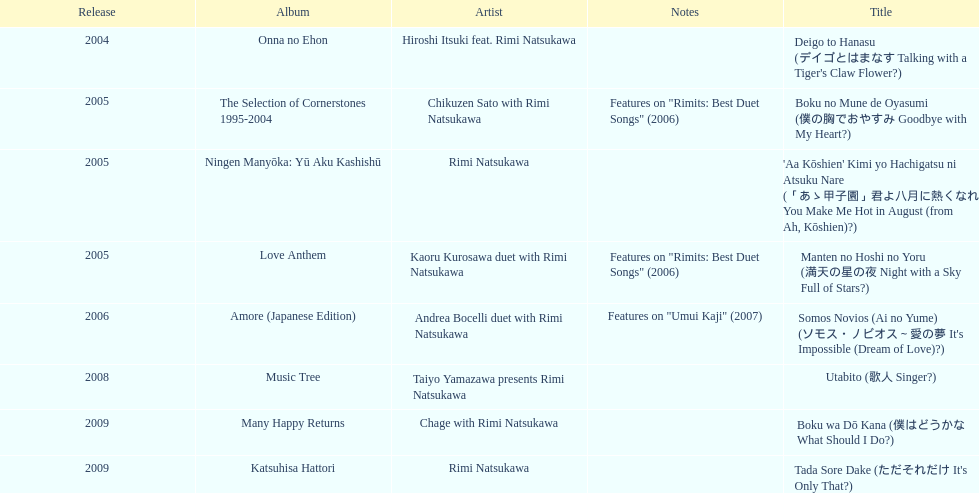Which was released earlier, deigo to hanasu or utabito? Deigo to Hanasu. 